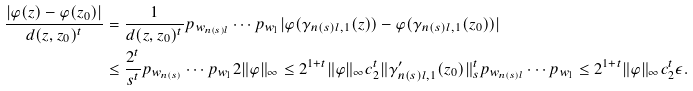<formula> <loc_0><loc_0><loc_500><loc_500>\frac { | \varphi ( z ) - \varphi ( z _ { 0 } ) | } { d ( z , z _ { 0 } ) ^ { t } } & = \frac { 1 } { d ( z , z _ { 0 } ) ^ { t } } p _ { w _ { n ( s ) l } } \cdots p _ { w _ { 1 } } | \varphi ( \gamma _ { n ( s ) l , 1 } ( z ) ) - \varphi ( \gamma _ { n ( s ) l , 1 } ( z _ { 0 } ) ) | \\ & \leq \frac { 2 ^ { t } } { s ^ { t } } p _ { w _ { n ( s ) } } \cdots p _ { w _ { 1 } } 2 \| \varphi \| _ { \infty } \leq 2 ^ { 1 + t } \| \varphi \| _ { \infty } c _ { 2 } ^ { t } \| \gamma _ { n ( s ) l , 1 } ^ { \prime } ( z _ { 0 } ) \| _ { s } ^ { t } p _ { w _ { n ( s ) l } } \cdots p _ { w _ { 1 } } \leq 2 ^ { 1 + t } \| \varphi \| _ { \infty } c _ { 2 } ^ { t } \epsilon .</formula> 